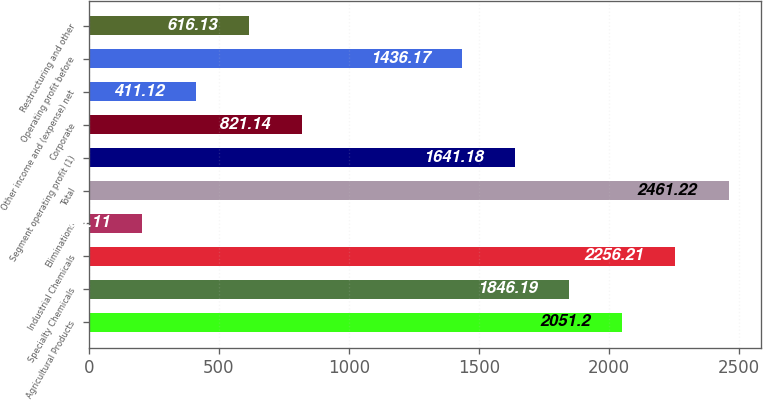Convert chart. <chart><loc_0><loc_0><loc_500><loc_500><bar_chart><fcel>Agricultural Products<fcel>Specialty Chemicals<fcel>Industrial Chemicals<fcel>Eliminations<fcel>Total<fcel>Segment operating profit (1)<fcel>Corporate<fcel>Other income and (expense) net<fcel>Operating profit before<fcel>Restructuring and other<nl><fcel>2051.2<fcel>1846.19<fcel>2256.21<fcel>206.11<fcel>2461.22<fcel>1641.18<fcel>821.14<fcel>411.12<fcel>1436.17<fcel>616.13<nl></chart> 